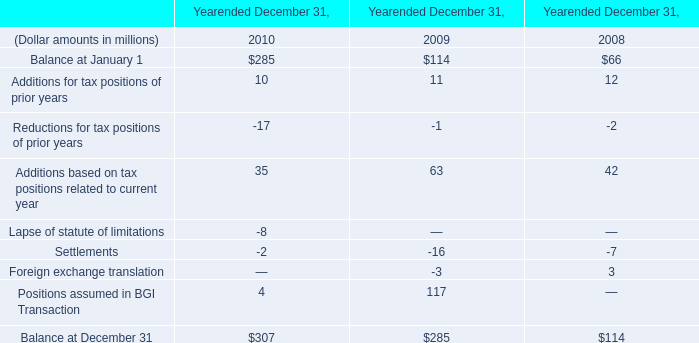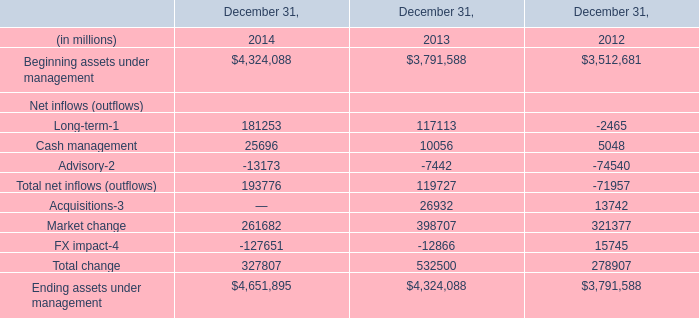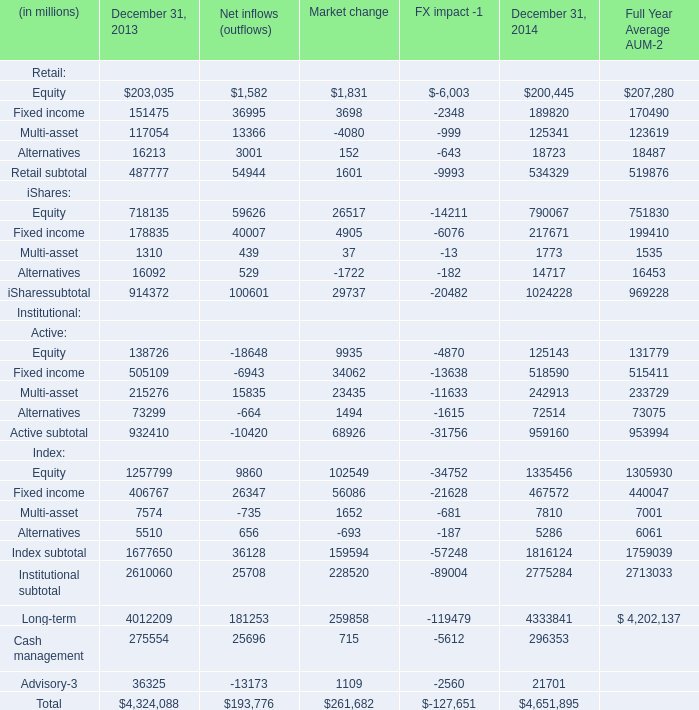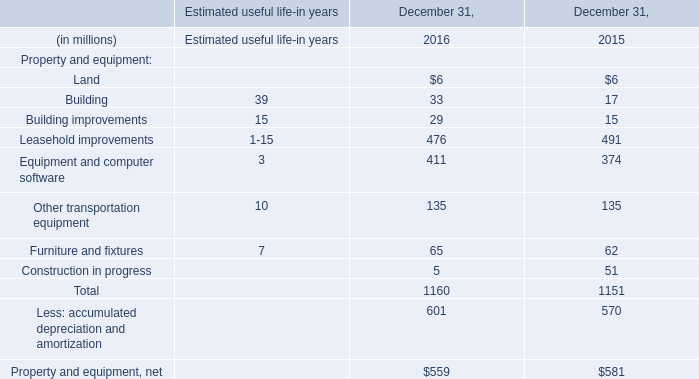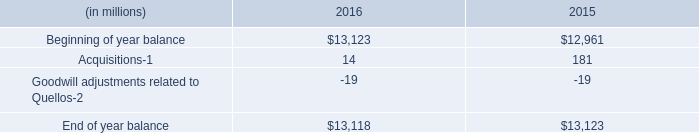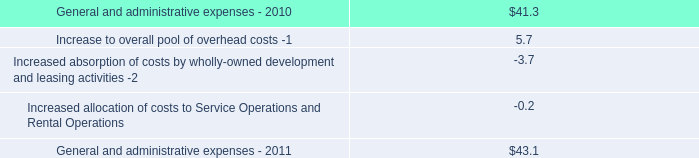what was the percentage increase in the general and administrative expenses from 2010 to 2011.\\n 
Computations: ((43.1 - 41.3) / 41.3)
Answer: 0.04358. 